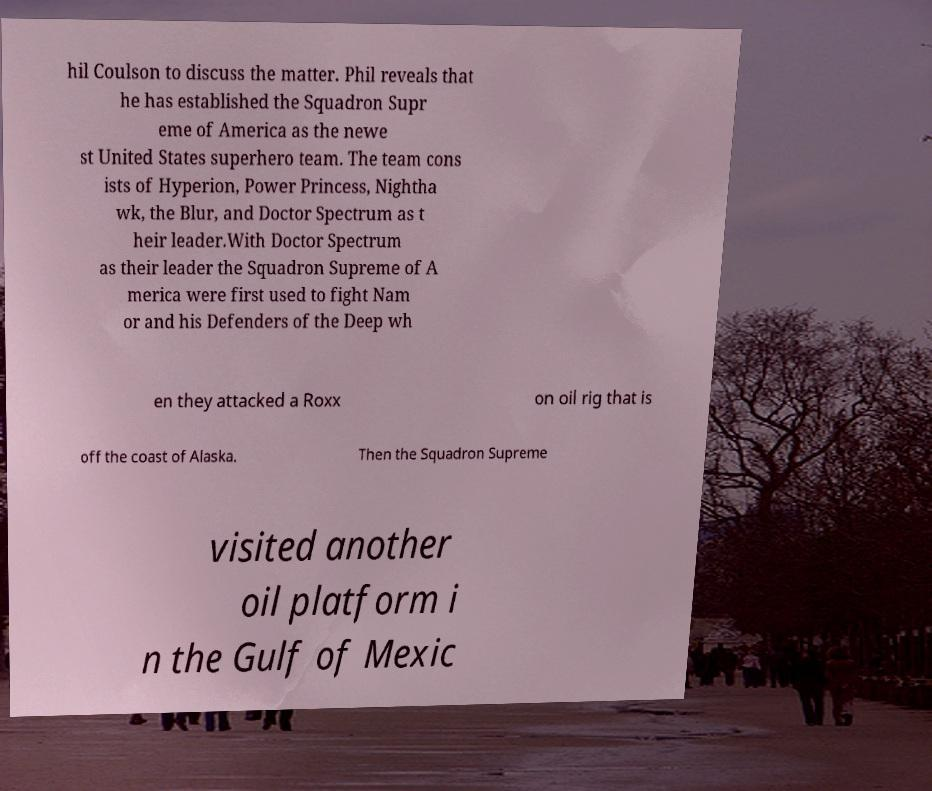Please read and relay the text visible in this image. What does it say? hil Coulson to discuss the matter. Phil reveals that he has established the Squadron Supr eme of America as the newe st United States superhero team. The team cons ists of Hyperion, Power Princess, Nightha wk, the Blur, and Doctor Spectrum as t heir leader.With Doctor Spectrum as their leader the Squadron Supreme of A merica were first used to fight Nam or and his Defenders of the Deep wh en they attacked a Roxx on oil rig that is off the coast of Alaska. Then the Squadron Supreme visited another oil platform i n the Gulf of Mexic 